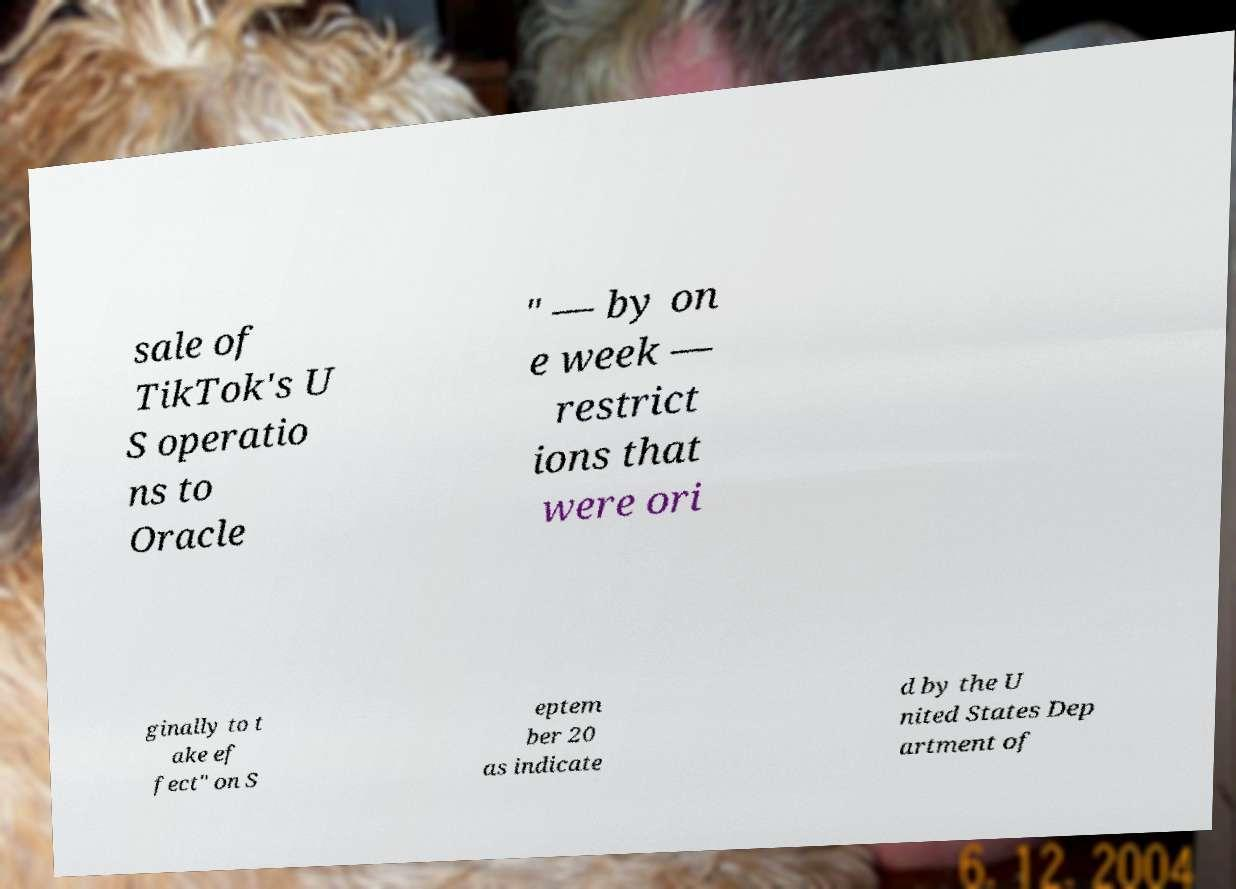There's text embedded in this image that I need extracted. Can you transcribe it verbatim? sale of TikTok's U S operatio ns to Oracle " — by on e week — restrict ions that were ori ginally to t ake ef fect" on S eptem ber 20 as indicate d by the U nited States Dep artment of 